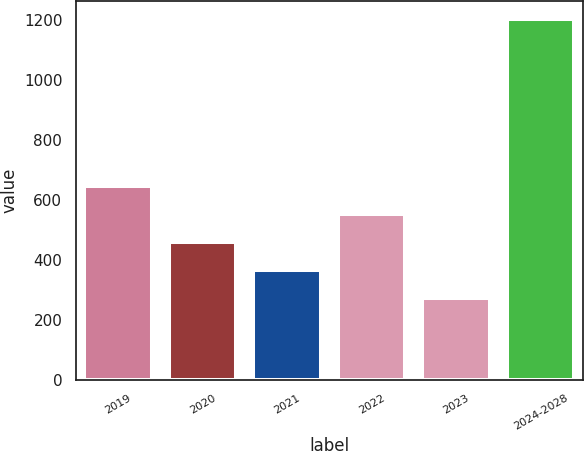<chart> <loc_0><loc_0><loc_500><loc_500><bar_chart><fcel>2019<fcel>2020<fcel>2021<fcel>2022<fcel>2023<fcel>2024-2028<nl><fcel>646.4<fcel>460.2<fcel>367.1<fcel>553.3<fcel>274<fcel>1205<nl></chart> 